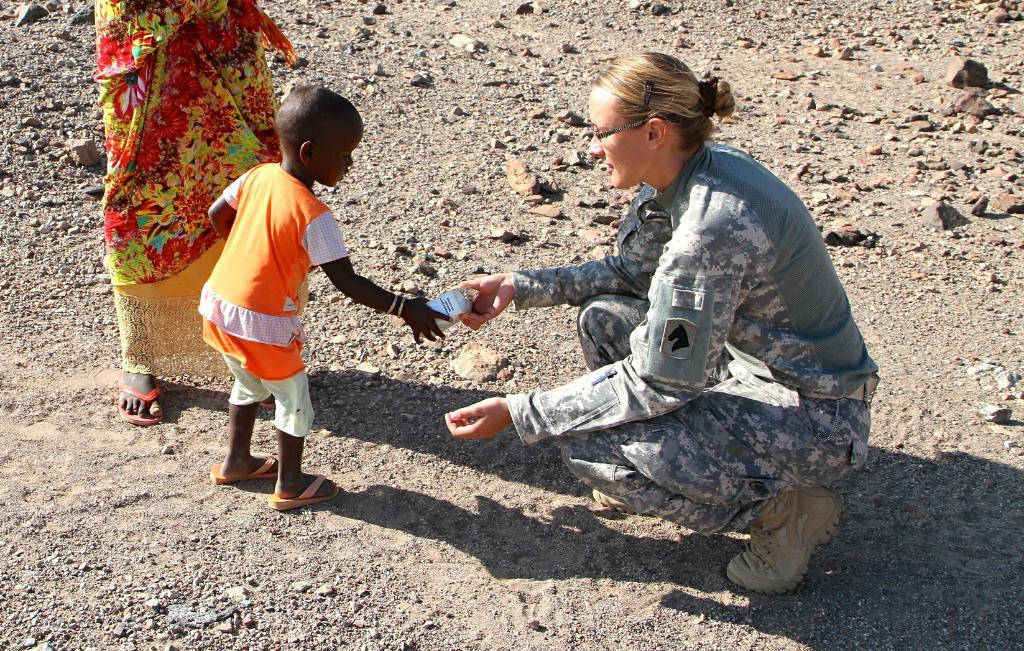Please provide a concise description of this image. In this image I can see two women and a girl. In the front I can see two of them are holding a white colour thing and on the right side I can see one of them is wearing uniform. I can also see number of stones and shadows on the ground. 